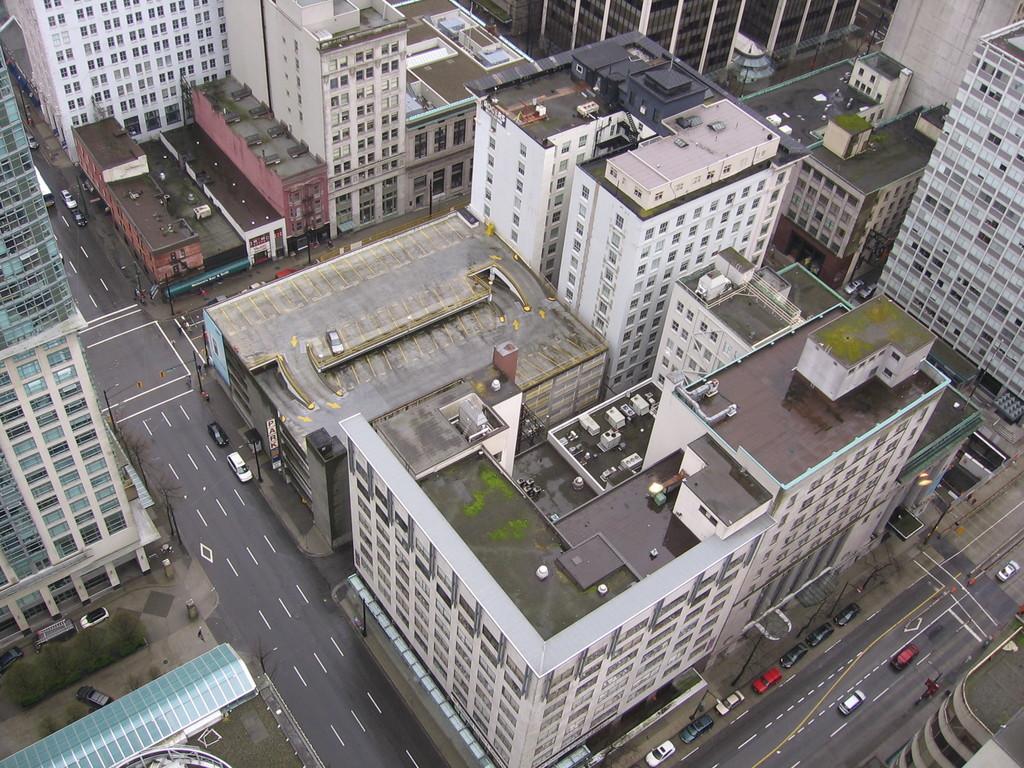Can you describe this image briefly? In the picture we can see a building and a road and some cars on it and to the buildings we can see a window and glasses. 